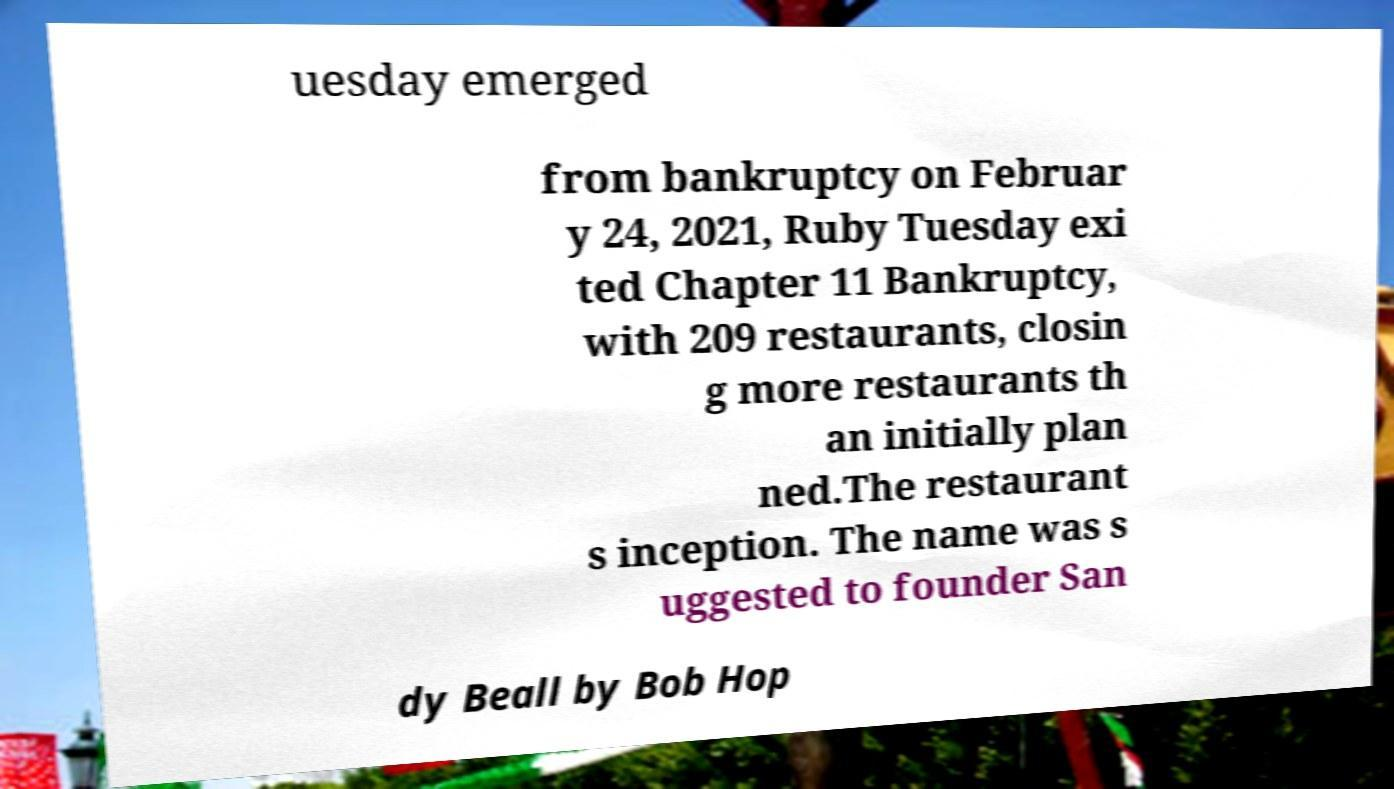I need the written content from this picture converted into text. Can you do that? uesday emerged from bankruptcy on Februar y 24, 2021, Ruby Tuesday exi ted Chapter 11 Bankruptcy, with 209 restaurants, closin g more restaurants th an initially plan ned.The restaurant s inception. The name was s uggested to founder San dy Beall by Bob Hop 